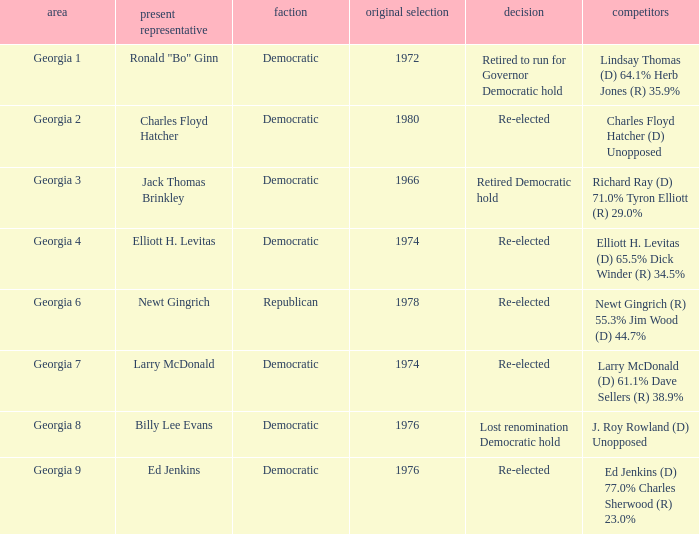Name the candidates for georgia 8 J. Roy Rowland (D) Unopposed. 